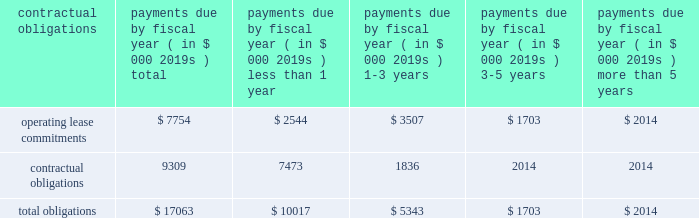97% ( 97 % ) of its carrying value .
The columbia fund is being liquidated with distributions to us occurring and expected to be fully liquidated during calendar 2008 .
Since december 2007 , we have received disbursements of approximately $ 20.7 million from the columbia fund .
Our operating activities during the year ended march 31 , 2008 used cash of $ 28.9 million as compared to $ 19.8 million during the same period in the prior year .
Our fiscal 2008 net loss of $ 40.9 million was the primary cause of our cash use from operations , attributed to increased investments in our global distribution as we continue to drive initiatives to increase recovery awareness as well as our investments in research and development to broaden our circulatory care product portfolio .
In addition , our inventories used cash of $ 11.1 million during fiscal 2008 , reflecting our inventory build-up to support anticipated increases in global demand for our products and our accounts receivable also increased as a result of higher sales volume resulting in a use of cash of $ 2.8 million in fiscal 2008 .
These decreases in cash were partially offset by an increase in accounts payable and accrued expenses of $ 5.6 million , non-cash adjustments of $ 5.4 million related to stock-based compensation expense , $ 6.1 million of depreciation and amortization and $ 5.0 million for the change in fair value of worldheart note receivable and warrant .
Our investing activities during the year ended march 31 , 2008 used cash of $ 40.9 million as compared to cash provided by investing activities of $ 15.1 million during the year ended march 31 , 2007 .
Cash used by investment activities for fiscal 2008 consisted primarily of $ 49.3 million for the recharacterization of the columbia fund to short-term marketable securities , $ 17.1 million for the purchase of short-term marketable securities , $ 3.8 million related to expenditures for property and equipment and $ 5.0 million for note receivable advanced to worldheart .
These amounts were offset by $ 34.5 million of proceeds from short-term marketable securities .
In june 2008 , we received 510 ( k ) clearance of our impella 2.5 , triggering an obligation to pay $ 5.6 million of contingent payments in accordance with the may 2005 acquisition of impella .
These contingent payments may be made , at our option , with cash , or stock or by a combination of cash or stock under circumstances described in the purchase agreement .
It is our intent to satisfy this contingent payment through the issuance of shares of our common stock .
Our financing activities during the year ended march 31 , 2008 provided cash of $ 2.1 million as compared to cash provided by financing activities of $ 66.6 million during the same period in the prior year .
Cash provided by financing activities for fiscal 2008 is comprised primarily of $ 2.8 million attributable to the exercise of stock options , $ 0.9 million related to the proceeds from the issuance of common stock , $ 0.3 million related to proceeds from the employee stock purchase plan , partially offset by $ 1.9 million related to the repurchase of warrants .
The $ 64.5 million decrease compared to the prior year is primarily due to $ 63.6 million raised from the public offering in fiscal 2007 .
We disbursed approximately $ 2.2 million of cash for the warrant repurchase and settlement of certain litigation .
Capital expenditures for fiscal 2009 are estimated to be approximately $ 3.0 to $ 6.0 million .
Contractual obligations and commercial commitments the table summarizes our contractual obligations at march 31 , 2008 and the effects such obligations are expected to have on our liquidity and cash flows in future periods .
Payments due by fiscal year ( in $ 000 2019s ) contractual obligations total than 1 than 5 .
We have no long-term debt , capital leases or other material commitments , for open purchase orders and clinical trial agreements at march 31 , 2008 other than those shown in the table above .
In may 2005 , we acquired all the shares of outstanding capital stock of impella cardiosystems ag , a company headquartered in aachen , germany .
The aggregate purchase price excluding a contingent payment in the amount of $ 5.6 million made on january 30 , 2007 in the form of common stock , was approximately $ 45.1 million , which consisted of $ 42.2 million of our common stock , $ 1.6 million of cash paid to certain former shareholders of impella and $ 1.3 million of transaction costs , consisting primarily of fees paid for financial advisory and legal services .
We may make additional contingent payments to impella 2019s former shareholders based on additional milestone payments related to fda approvals in the amount of up to $ 11.2 million .
In june 2008 we received 510 ( k ) clearance of our impella 2.5 , triggering an obligation to pay $ 5.6 million of contingent payments .
These contingent payments may be made , at our option , with cash , or stock or by a combination of cash or stock under circumstances described in the purchase agreement , except that approximately $ 1.8 million of these contingent payments must be made in cash .
The payment of any contingent payments will result in an increase to the carrying value of goodwill .
We apply the disclosure provisions of fin no .
45 , guarantor 2019s accounting and disclosure requirements for guarantees , including guarantees of indebtedness of others , and interpretation of fasb statements no .
5 , 57 and 107 and rescission of fasb interpretation .
What would be the total purchase price of impella cardiosystems assuming all contingent consideration is earned , in millions? 
Computations: (11.2 + 45.1)
Answer: 56.3. 